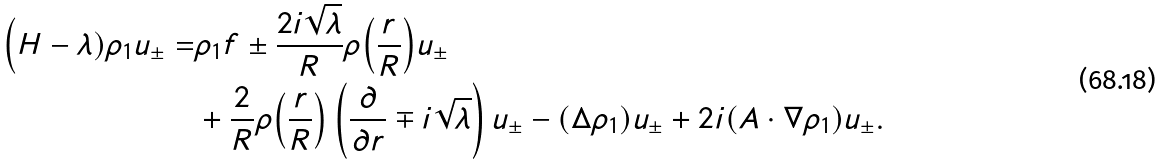Convert formula to latex. <formula><loc_0><loc_0><loc_500><loc_500>\Big ( H - \lambda ) \rho _ { 1 } u _ { \pm } = & \rho _ { 1 } f \pm \frac { 2 i \sqrt { \lambda } } { R } \rho \Big ( \frac { r } { R } \Big ) u _ { \pm } \\ & + \frac { 2 } { R } \rho \Big ( \frac { r } { R } \Big ) \left ( \frac { \partial } { \partial r } \mp i \sqrt { \lambda } \right ) u _ { \pm } - ( \Delta \rho _ { 1 } ) u _ { \pm } + 2 i ( A \cdot \nabla \rho _ { 1 } ) u _ { \pm } .</formula> 